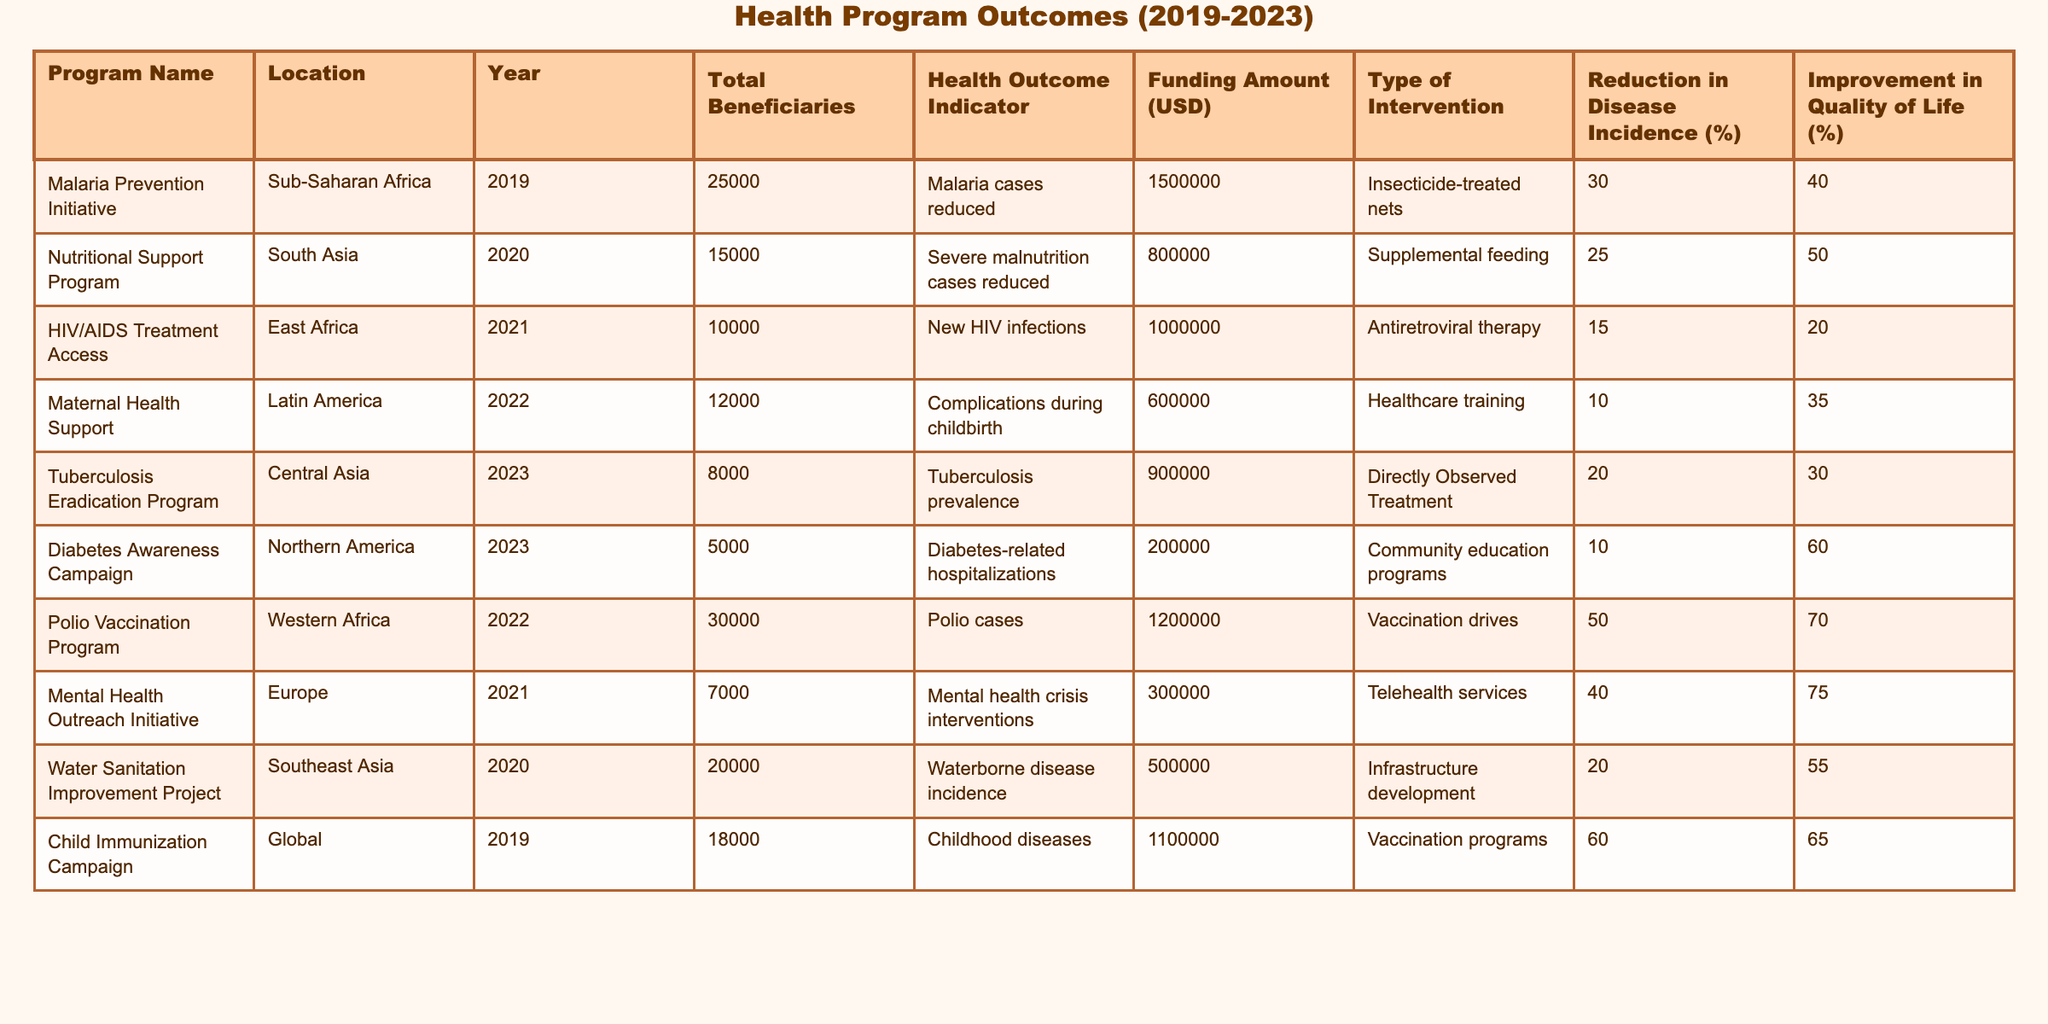What is the total funding amount for the Malaria Prevention Initiative? The funding amount for the Malaria Prevention Initiative is listed as 1,500,000 USD in the table.
Answer: 1,500,000 USD Which program has the highest reduction in disease incidence? By reviewing the "Reduction in Disease Incidence (%)" column, the Polio Vaccination Program has the highest reduction rate of 50%.
Answer: Polio Vaccination Program What is the average amount of funding across all programs? The total funding from the table is (1,500,000 + 800,000 + 1,000,000 + 600,000 + 900,000 + 200,000 + 1,200,000 + 300,000 + 500,000 + 1,100,000) = 7,100,000 USD. There are 10 programs, so the average funding is 7,100,000 / 10 = 710,000 USD.
Answer: 710,000 USD How many programs reported an improvement in quality of life of at least 60%? By checking the "Improvement in Quality of Life (%)" column, the Diabetes Awareness Campaign (60%) and the Polio Vaccination Program (70%) both reported improvements of at least 60%. Therefore, there are two such programs.
Answer: 2 Did the Nutritional Support Program achieve a reduction in severe malnutrition cases? Yes, the Nutritional Support Program is indicated to have reduced severe malnutrition cases by 25%.
Answer: Yes Which intervention type had the lowest improvement in quality of life percentage? The "Type of Intervention" and "Improvement in Quality of Life (%)" columns show that the HIV/AIDS Treatment Access program had the lowest improvement at 20%.
Answer: HIV/AIDS Treatment Access Calculate the total number of beneficiaries from the health programs in South Asia. The only program listed in South Asia is the Nutritional Support Program with 15,000 beneficiaries. So, the total is 15,000.
Answer: 15,000 Is it true that all programs funded in 2021 had improvement in quality of life? By examining the 2021 programs, the HIV/AIDS Treatment Access program (20% improvement) and Mental Health Outreach Initiative (75% improvement) both had improvements, therefore the statement is true.
Answer: Yes What was the year with the highest number of beneficiaries across all programs? The Child Immunization Campaign in 2019 had the highest number of beneficiaries at 18,000 compared to other years. On summation, 30,000 (Polio) in 2022 is also higher, thus it’s the year 2022.
Answer: 2022 What percentage of programs had a funding amount of over 1 million USD? There are 5 programs that had a funding amount exceeding 1 million USD (Malaria Prevention Initiative, HIV/AIDS Treatment Access, Polio Vaccination Program, Child Immunization Campaign, and Nutritional Support Program), out of 10 programs, which gives 50%.
Answer: 50% 